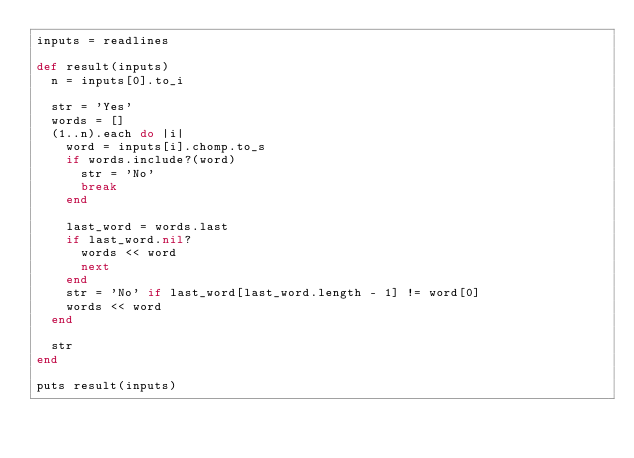Convert code to text. <code><loc_0><loc_0><loc_500><loc_500><_Ruby_>inputs = readlines

def result(inputs)
  n = inputs[0].to_i

  str = 'Yes'
  words = []
  (1..n).each do |i|
    word = inputs[i].chomp.to_s
    if words.include?(word)
      str = 'No'
      break
    end

    last_word = words.last
    if last_word.nil?
      words << word
      next
    end
    str = 'No' if last_word[last_word.length - 1] != word[0]
    words << word
  end

  str
end

puts result(inputs)</code> 